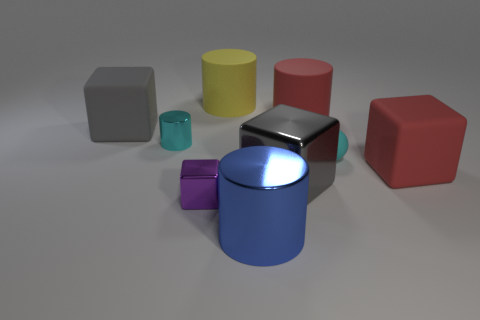Subtract all gray blocks. How many were subtracted if there are1gray blocks left? 1 Subtract all red blocks. How many blocks are left? 3 Subtract all brown cylinders. Subtract all red spheres. How many cylinders are left? 4 Add 1 small metal blocks. How many objects exist? 10 Subtract all balls. How many objects are left? 8 Subtract 0 yellow cubes. How many objects are left? 9 Subtract all big cyan cylinders. Subtract all big cubes. How many objects are left? 6 Add 2 cyan shiny things. How many cyan shiny things are left? 3 Add 7 tiny purple metal things. How many tiny purple metal things exist? 8 